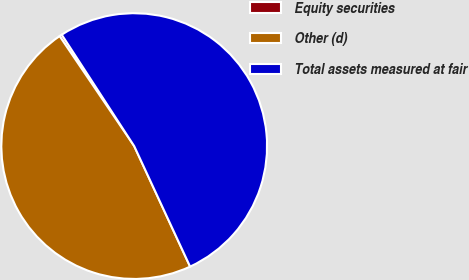Convert chart to OTSL. <chart><loc_0><loc_0><loc_500><loc_500><pie_chart><fcel>Equity securities<fcel>Other (d)<fcel>Total assets measured at fair<nl><fcel>0.31%<fcel>47.42%<fcel>52.26%<nl></chart> 